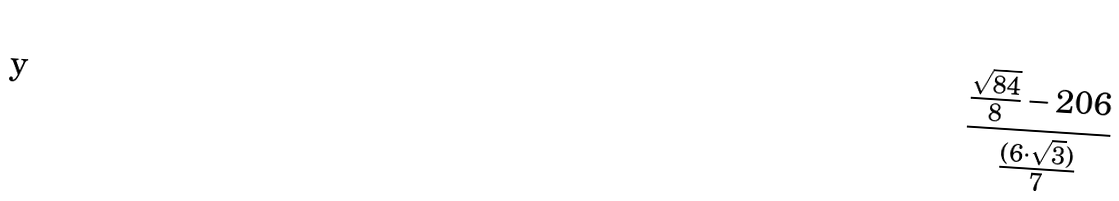<formula> <loc_0><loc_0><loc_500><loc_500>\frac { \frac { \sqrt { 8 4 } } { 8 } - 2 0 6 } { \frac { ( 6 \cdot \sqrt { 3 } ) } { 7 } }</formula> 